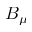Convert formula to latex. <formula><loc_0><loc_0><loc_500><loc_500>B _ { \mu }</formula> 